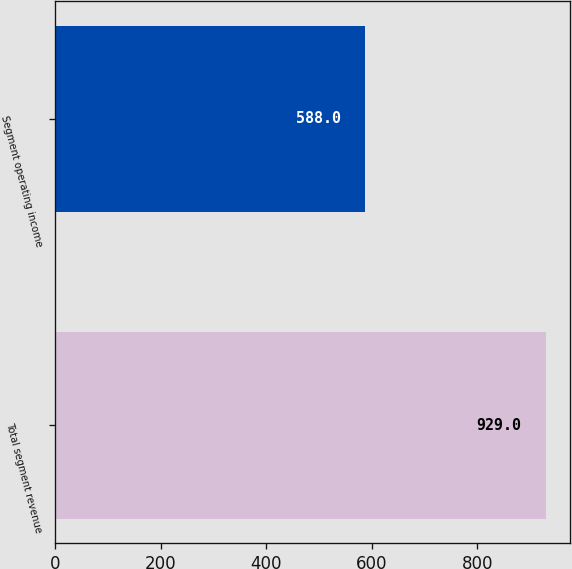<chart> <loc_0><loc_0><loc_500><loc_500><bar_chart><fcel>Total segment revenue<fcel>Segment operating income<nl><fcel>929<fcel>588<nl></chart> 